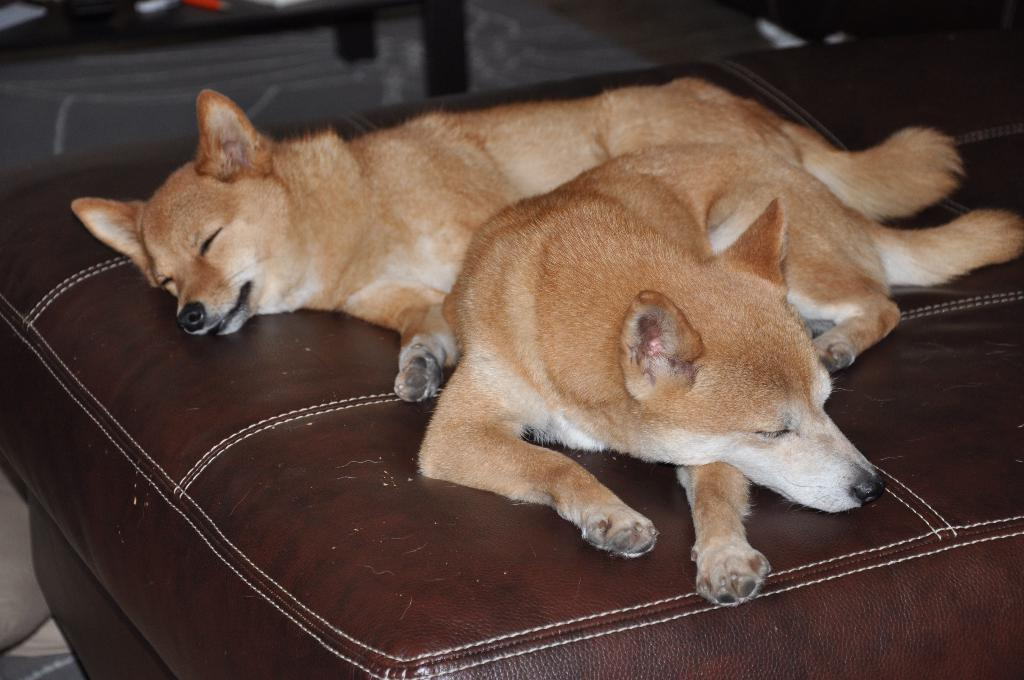How many dogs are present in the image? There are two dogs in the image. Where are the dogs located? The dogs are on a bed. Can you describe the background of the image? There are objects visible in the background of the image. What type of comb is being used by the dogs in the image? There is no comb present in the image, and the dogs are not using any comb. 